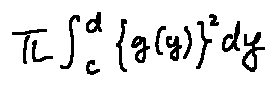<formula> <loc_0><loc_0><loc_500><loc_500>\pi \int \lim i t s _ { c } ^ { d } \{ g ( y ) \} ^ { 2 } d y</formula> 